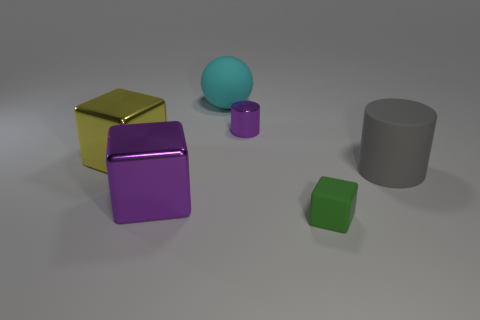There is a purple metallic cylinder; does it have the same size as the matte object that is behind the large yellow thing?
Provide a short and direct response. No. Are there any other things that are the same color as the tiny metal cylinder?
Your response must be concise. Yes. Is there a metal thing that has the same color as the metallic cylinder?
Give a very brief answer. Yes. Do the big yellow metal object and the big rubber object that is in front of the large cyan object have the same shape?
Provide a succinct answer. No. How many objects are both on the left side of the large purple thing and to the right of the cyan matte sphere?
Offer a very short reply. 0. What is the material of the big purple thing that is the same shape as the green thing?
Make the answer very short. Metal. How big is the object that is in front of the large shiny block that is in front of the big gray cylinder?
Offer a very short reply. Small. Are any big cyan rubber balls visible?
Your response must be concise. Yes. There is a large object that is left of the big matte cylinder and in front of the large yellow metal object; what is its material?
Your answer should be compact. Metal. Are there more objects behind the small green thing than rubber cylinders that are to the right of the gray cylinder?
Your response must be concise. Yes. 